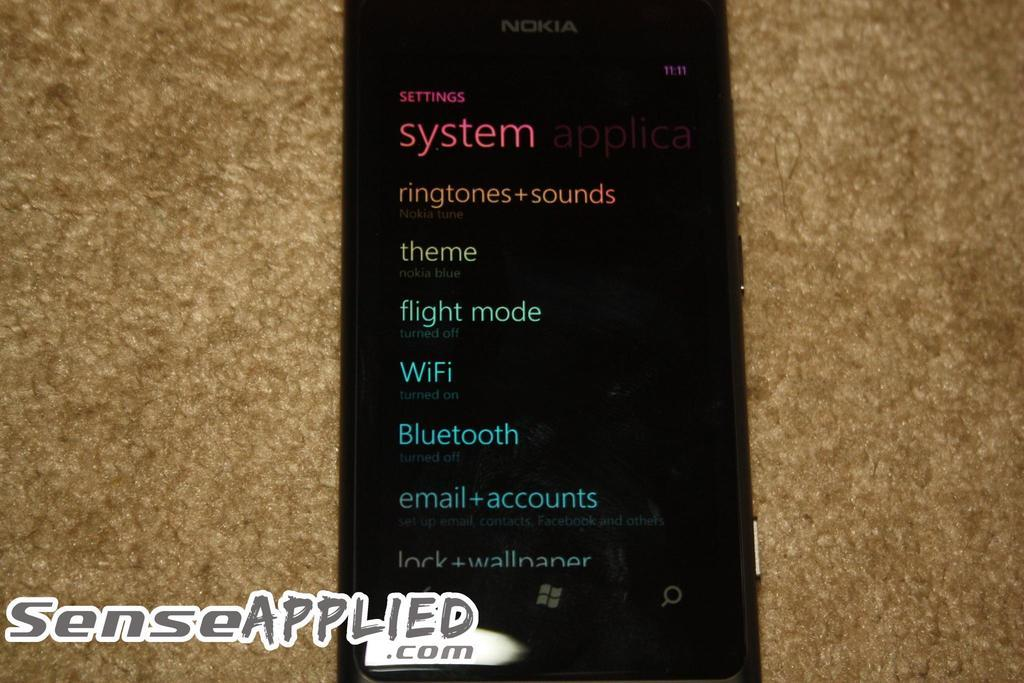Provide a one-sentence caption for the provided image. A black Nokia cell phone displaying different system settings for apps. 